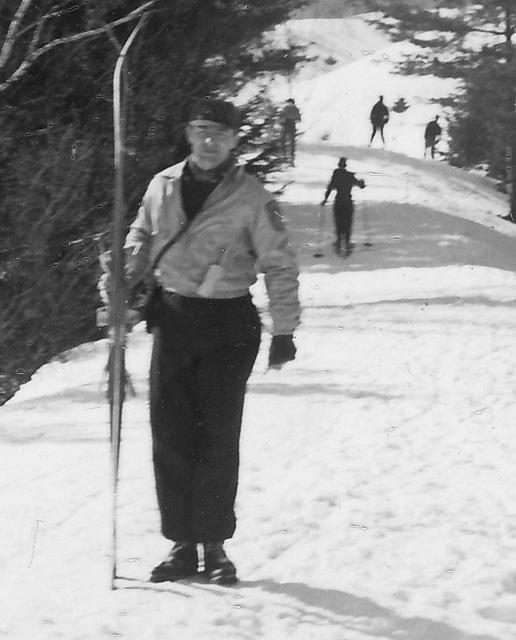How many ski are in the photo?
Give a very brief answer. 1. How many people are visible?
Give a very brief answer. 2. 